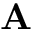<formula> <loc_0><loc_0><loc_500><loc_500>A</formula> 